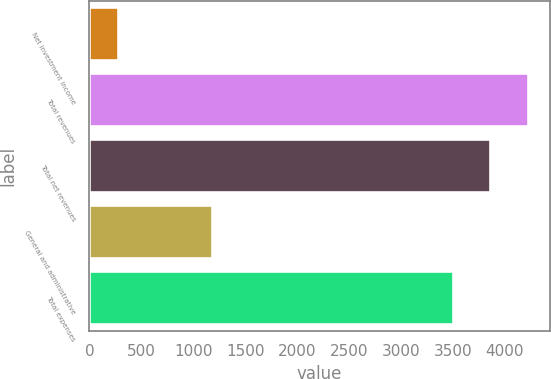<chart> <loc_0><loc_0><loc_500><loc_500><bar_chart><fcel>Net investment income<fcel>Total revenues<fcel>Total net revenues<fcel>General and administrative<fcel>Total expenses<nl><fcel>276<fcel>4222<fcel>3862<fcel>1179<fcel>3502<nl></chart> 